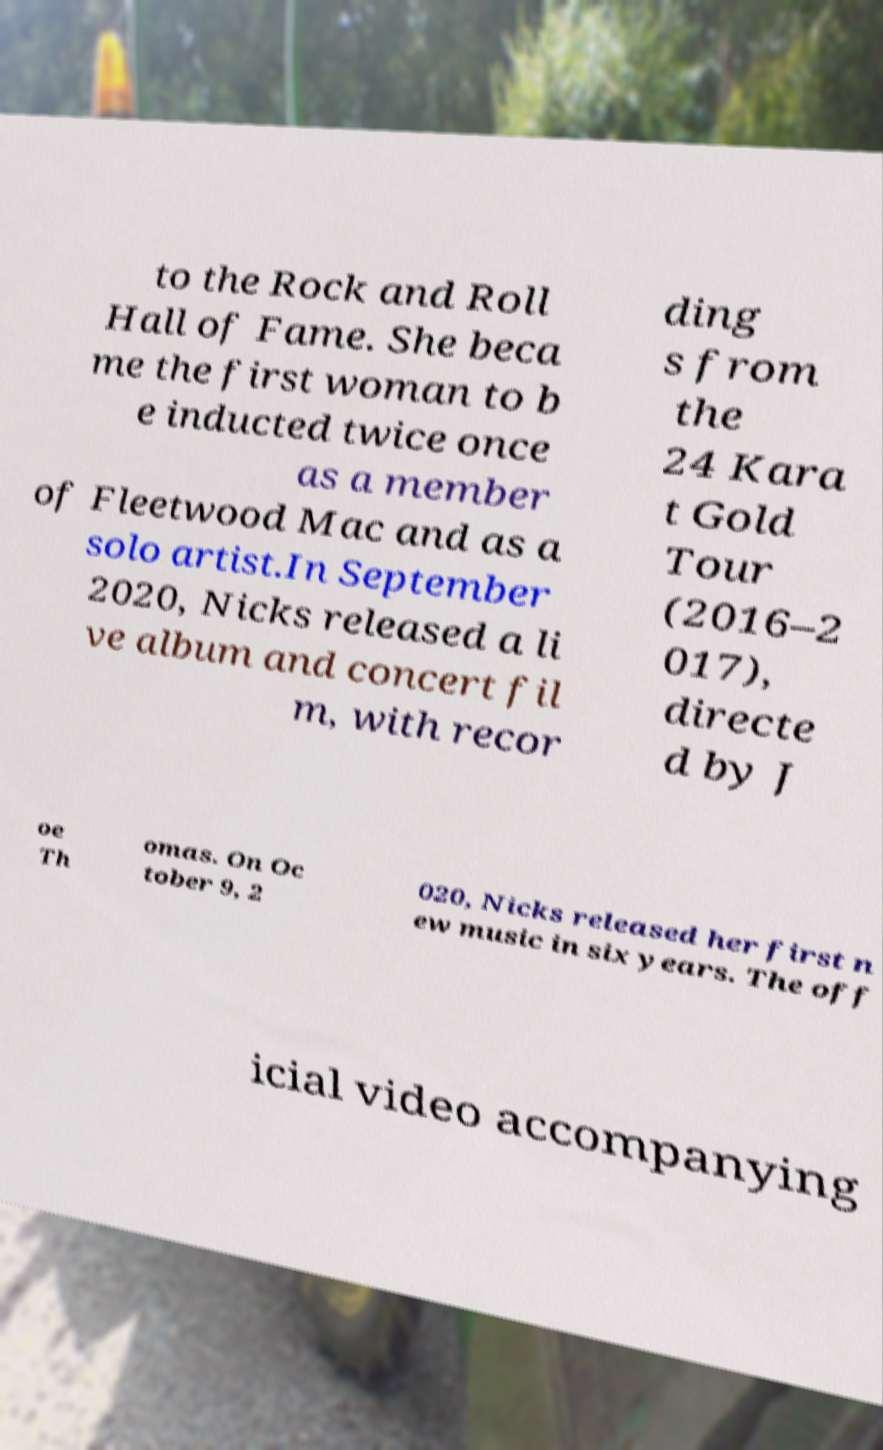What messages or text are displayed in this image? I need them in a readable, typed format. to the Rock and Roll Hall of Fame. She beca me the first woman to b e inducted twice once as a member of Fleetwood Mac and as a solo artist.In September 2020, Nicks released a li ve album and concert fil m, with recor ding s from the 24 Kara t Gold Tour (2016–2 017), directe d by J oe Th omas. On Oc tober 9, 2 020, Nicks released her first n ew music in six years. The off icial video accompanying 